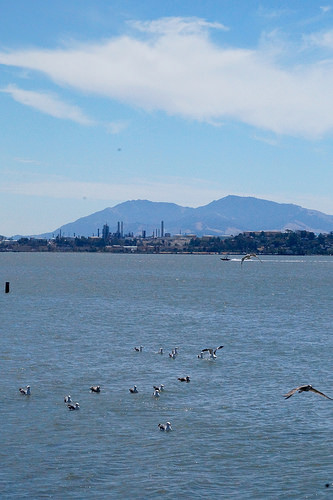<image>
Is there a bird on the water? Yes. Looking at the image, I can see the bird is positioned on top of the water, with the water providing support. Where is the water in relation to the mountain? Is it behind the mountain? No. The water is not behind the mountain. From this viewpoint, the water appears to be positioned elsewhere in the scene. 